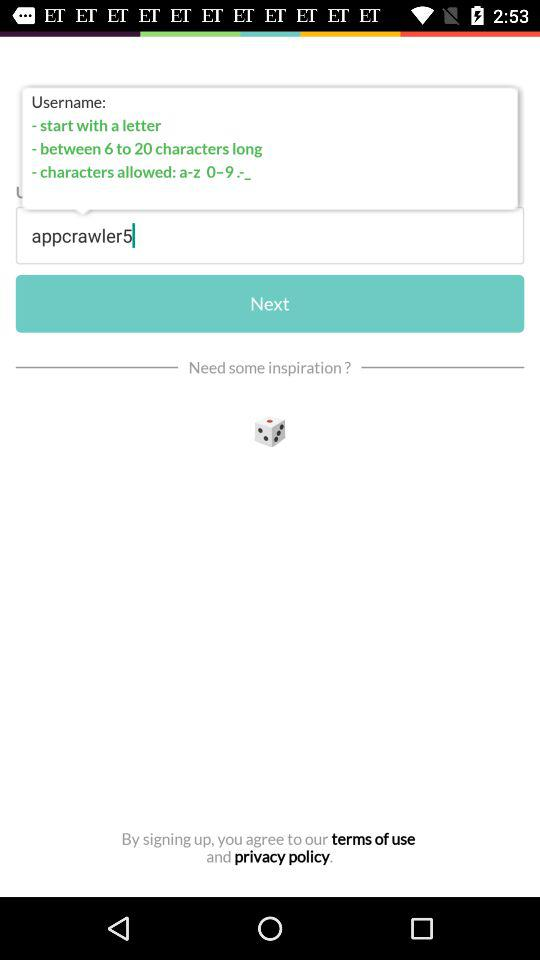What types of characters are allowed? The allowed character types are "a-z", "0-9" and ".-_". 